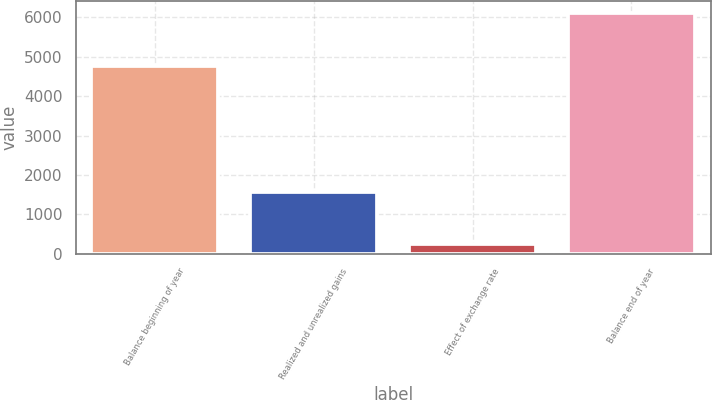Convert chart. <chart><loc_0><loc_0><loc_500><loc_500><bar_chart><fcel>Balance beginning of year<fcel>Realized and unrealized gains<fcel>Effect of exchange rate<fcel>Balance end of year<nl><fcel>4776<fcel>1572<fcel>237<fcel>6111<nl></chart> 